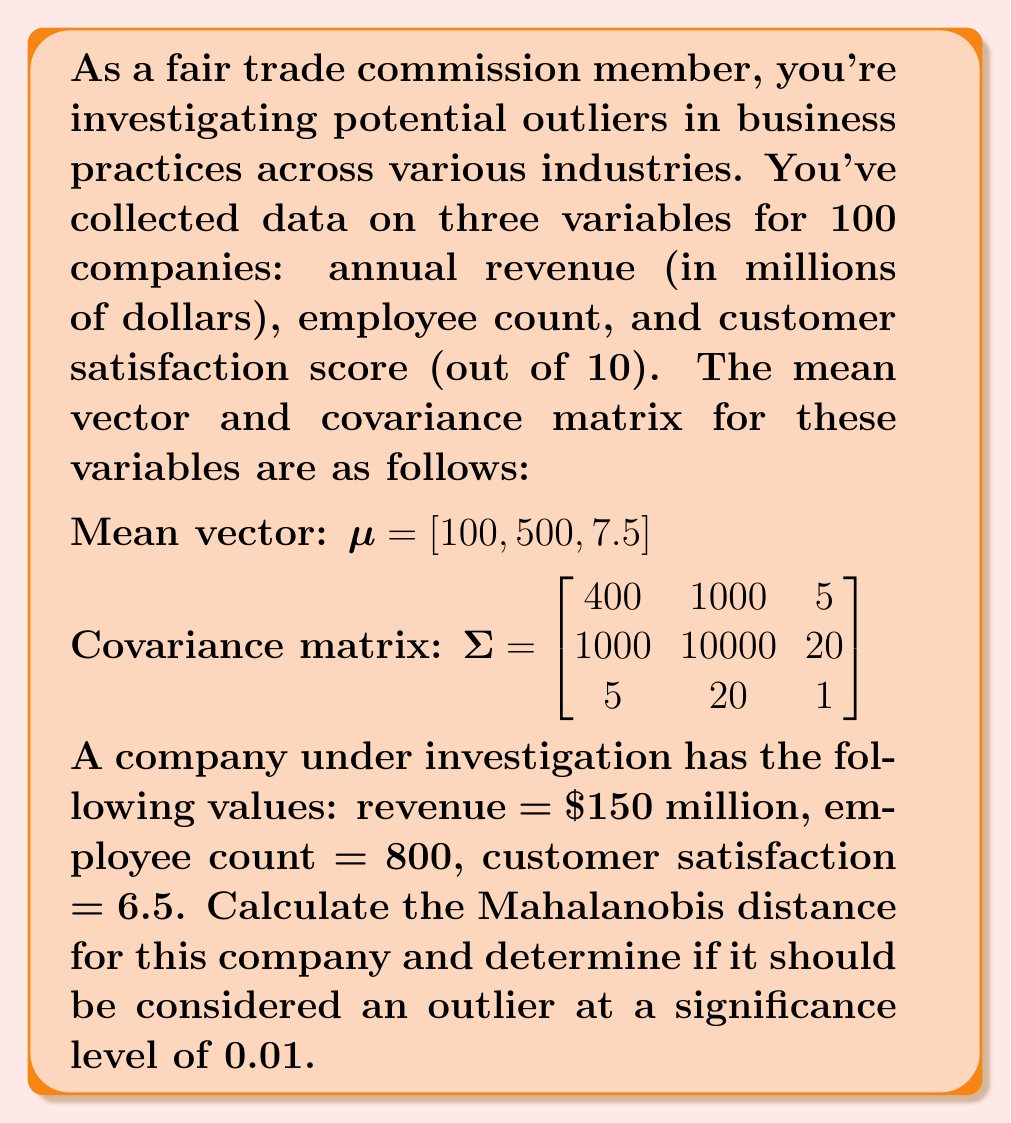Could you help me with this problem? To solve this problem, we'll follow these steps:

1) First, recall the formula for Mahalanobis distance:

   $$ D^2 = (x - \mu)^T \Sigma^{-1} (x - \mu) $$

   where $x$ is the observation vector, $\mu$ is the mean vector, and $\Sigma$ is the covariance matrix.

2) We have:
   $x = [150, 800, 6.5]$
   $\mu = [100, 500, 7.5]$

3) Calculate $(x - \mu)$:
   $x - \mu = [50, 300, -1]$

4) To calculate $\Sigma^{-1}$, we need to invert the covariance matrix. Using a calculator or computer algebra system, we get:

   $$ \Sigma^{-1} = \begin{bmatrix}
   0.00263 & -0.00026 & -0.01184 \\
   -0.00026 & 0.00011 & -0.00047 \\
   -0.01184 & -0.00047 & 1.01595
   \end{bmatrix} $$

5) Now we can calculate the Mahalanobis distance:

   $$ D^2 = [50, 300, -1] \begin{bmatrix}
   0.00263 & -0.00026 & -0.01184 \\
   -0.00026 & 0.00011 & -0.00047 \\
   -0.01184 & -0.00047 & 1.01595
   \end{bmatrix} \begin{bmatrix} 50 \\ 300 \\ -1 \end{bmatrix} $$

6) Multiplying these matrices gives us:

   $D^2 = 11.8676$

7) Taking the square root:

   $D = \sqrt{11.8676} = 3.4449$

8) To determine if this is an outlier, we compare it to the critical value of the chi-square distribution with 3 degrees of freedom (as we have 3 variables) at the 0.01 significance level.

   The critical value is 11.3449.

9) Since our calculated $D^2 (11.8676) > 11.3449$, we consider this company an outlier.
Answer: The Mahalanobis distance for the company is 3.4449. Since the squared Mahalanobis distance (11.8676) exceeds the critical value of 11.3449, the company is considered an outlier at the 0.01 significance level. 